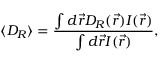<formula> <loc_0><loc_0><loc_500><loc_500>\langle D _ { R } \rangle = \frac { \int d \vec { r } D _ { R } ( \vec { r } ) I ( \vec { r } ) } { \int d \vec { r } I ( \vec { r } ) } ,</formula> 